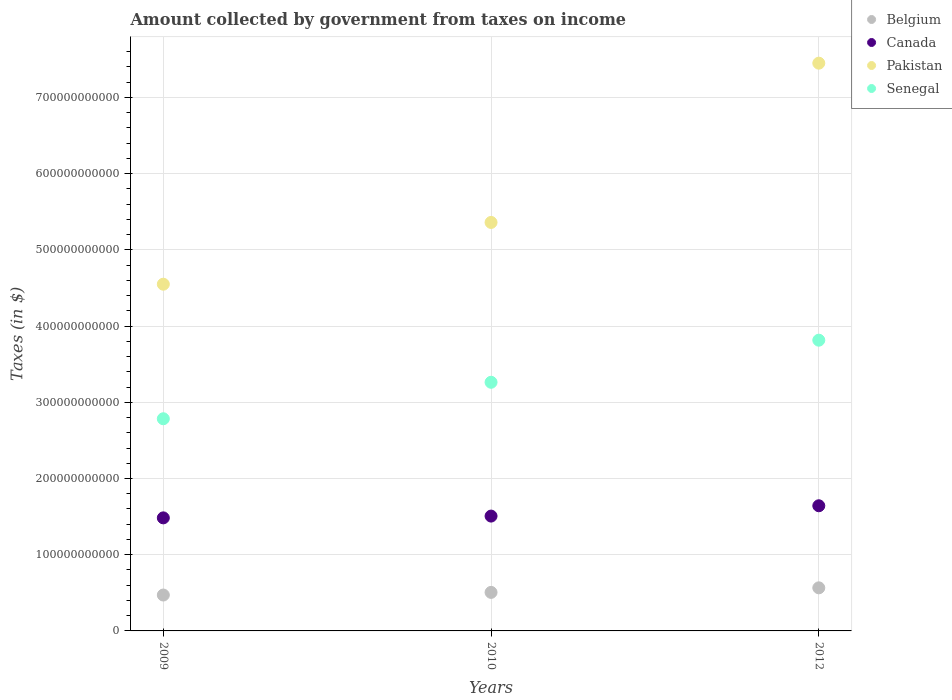How many different coloured dotlines are there?
Make the answer very short. 4. What is the amount collected by government from taxes on income in Senegal in 2010?
Offer a terse response. 3.26e+11. Across all years, what is the maximum amount collected by government from taxes on income in Belgium?
Your answer should be very brief. 5.65e+1. Across all years, what is the minimum amount collected by government from taxes on income in Belgium?
Provide a short and direct response. 4.71e+1. In which year was the amount collected by government from taxes on income in Senegal maximum?
Keep it short and to the point. 2012. What is the total amount collected by government from taxes on income in Pakistan in the graph?
Provide a succinct answer. 1.74e+12. What is the difference between the amount collected by government from taxes on income in Belgium in 2009 and that in 2012?
Your answer should be compact. -9.45e+09. What is the difference between the amount collected by government from taxes on income in Senegal in 2012 and the amount collected by government from taxes on income in Belgium in 2009?
Your answer should be compact. 3.34e+11. What is the average amount collected by government from taxes on income in Pakistan per year?
Your response must be concise. 5.79e+11. In the year 2012, what is the difference between the amount collected by government from taxes on income in Senegal and amount collected by government from taxes on income in Canada?
Your answer should be very brief. 2.17e+11. What is the ratio of the amount collected by government from taxes on income in Senegal in 2010 to that in 2012?
Ensure brevity in your answer.  0.86. Is the difference between the amount collected by government from taxes on income in Senegal in 2009 and 2010 greater than the difference between the amount collected by government from taxes on income in Canada in 2009 and 2010?
Provide a short and direct response. No. What is the difference between the highest and the second highest amount collected by government from taxes on income in Belgium?
Ensure brevity in your answer.  5.98e+09. What is the difference between the highest and the lowest amount collected by government from taxes on income in Senegal?
Your response must be concise. 1.03e+11. Is the sum of the amount collected by government from taxes on income in Canada in 2009 and 2012 greater than the maximum amount collected by government from taxes on income in Belgium across all years?
Your answer should be very brief. Yes. Is it the case that in every year, the sum of the amount collected by government from taxes on income in Pakistan and amount collected by government from taxes on income in Senegal  is greater than the amount collected by government from taxes on income in Canada?
Provide a short and direct response. Yes. How many dotlines are there?
Provide a short and direct response. 4. What is the difference between two consecutive major ticks on the Y-axis?
Provide a short and direct response. 1.00e+11. Where does the legend appear in the graph?
Provide a succinct answer. Top right. How are the legend labels stacked?
Your answer should be compact. Vertical. What is the title of the graph?
Ensure brevity in your answer.  Amount collected by government from taxes on income. What is the label or title of the X-axis?
Give a very brief answer. Years. What is the label or title of the Y-axis?
Your answer should be very brief. Taxes (in $). What is the Taxes (in $) in Belgium in 2009?
Offer a very short reply. 4.71e+1. What is the Taxes (in $) of Canada in 2009?
Keep it short and to the point. 1.48e+11. What is the Taxes (in $) in Pakistan in 2009?
Give a very brief answer. 4.55e+11. What is the Taxes (in $) in Senegal in 2009?
Make the answer very short. 2.78e+11. What is the Taxes (in $) in Belgium in 2010?
Make the answer very short. 5.06e+1. What is the Taxes (in $) in Canada in 2010?
Provide a succinct answer. 1.51e+11. What is the Taxes (in $) in Pakistan in 2010?
Make the answer very short. 5.36e+11. What is the Taxes (in $) of Senegal in 2010?
Your answer should be very brief. 3.26e+11. What is the Taxes (in $) in Belgium in 2012?
Your response must be concise. 5.65e+1. What is the Taxes (in $) in Canada in 2012?
Give a very brief answer. 1.64e+11. What is the Taxes (in $) in Pakistan in 2012?
Provide a short and direct response. 7.45e+11. What is the Taxes (in $) in Senegal in 2012?
Make the answer very short. 3.82e+11. Across all years, what is the maximum Taxes (in $) in Belgium?
Your response must be concise. 5.65e+1. Across all years, what is the maximum Taxes (in $) in Canada?
Provide a succinct answer. 1.64e+11. Across all years, what is the maximum Taxes (in $) of Pakistan?
Your response must be concise. 7.45e+11. Across all years, what is the maximum Taxes (in $) in Senegal?
Your answer should be compact. 3.82e+11. Across all years, what is the minimum Taxes (in $) of Belgium?
Your response must be concise. 4.71e+1. Across all years, what is the minimum Taxes (in $) in Canada?
Give a very brief answer. 1.48e+11. Across all years, what is the minimum Taxes (in $) of Pakistan?
Provide a short and direct response. 4.55e+11. Across all years, what is the minimum Taxes (in $) of Senegal?
Your answer should be very brief. 2.78e+11. What is the total Taxes (in $) of Belgium in the graph?
Provide a short and direct response. 1.54e+11. What is the total Taxes (in $) in Canada in the graph?
Provide a succinct answer. 4.63e+11. What is the total Taxes (in $) in Pakistan in the graph?
Offer a very short reply. 1.74e+12. What is the total Taxes (in $) of Senegal in the graph?
Keep it short and to the point. 9.86e+11. What is the difference between the Taxes (in $) of Belgium in 2009 and that in 2010?
Give a very brief answer. -3.46e+09. What is the difference between the Taxes (in $) of Canada in 2009 and that in 2010?
Offer a terse response. -2.34e+09. What is the difference between the Taxes (in $) of Pakistan in 2009 and that in 2010?
Your response must be concise. -8.10e+1. What is the difference between the Taxes (in $) of Senegal in 2009 and that in 2010?
Make the answer very short. -4.79e+1. What is the difference between the Taxes (in $) of Belgium in 2009 and that in 2012?
Provide a short and direct response. -9.45e+09. What is the difference between the Taxes (in $) of Canada in 2009 and that in 2012?
Ensure brevity in your answer.  -1.59e+1. What is the difference between the Taxes (in $) of Pakistan in 2009 and that in 2012?
Give a very brief answer. -2.90e+11. What is the difference between the Taxes (in $) of Senegal in 2009 and that in 2012?
Keep it short and to the point. -1.03e+11. What is the difference between the Taxes (in $) in Belgium in 2010 and that in 2012?
Give a very brief answer. -5.98e+09. What is the difference between the Taxes (in $) in Canada in 2010 and that in 2012?
Ensure brevity in your answer.  -1.35e+1. What is the difference between the Taxes (in $) in Pakistan in 2010 and that in 2012?
Offer a terse response. -2.09e+11. What is the difference between the Taxes (in $) in Senegal in 2010 and that in 2012?
Offer a very short reply. -5.52e+1. What is the difference between the Taxes (in $) of Belgium in 2009 and the Taxes (in $) of Canada in 2010?
Provide a short and direct response. -1.04e+11. What is the difference between the Taxes (in $) in Belgium in 2009 and the Taxes (in $) in Pakistan in 2010?
Your response must be concise. -4.89e+11. What is the difference between the Taxes (in $) in Belgium in 2009 and the Taxes (in $) in Senegal in 2010?
Keep it short and to the point. -2.79e+11. What is the difference between the Taxes (in $) of Canada in 2009 and the Taxes (in $) of Pakistan in 2010?
Provide a succinct answer. -3.88e+11. What is the difference between the Taxes (in $) of Canada in 2009 and the Taxes (in $) of Senegal in 2010?
Offer a very short reply. -1.78e+11. What is the difference between the Taxes (in $) of Pakistan in 2009 and the Taxes (in $) of Senegal in 2010?
Your response must be concise. 1.29e+11. What is the difference between the Taxes (in $) in Belgium in 2009 and the Taxes (in $) in Canada in 2012?
Provide a short and direct response. -1.17e+11. What is the difference between the Taxes (in $) of Belgium in 2009 and the Taxes (in $) of Pakistan in 2012?
Your response must be concise. -6.98e+11. What is the difference between the Taxes (in $) in Belgium in 2009 and the Taxes (in $) in Senegal in 2012?
Ensure brevity in your answer.  -3.34e+11. What is the difference between the Taxes (in $) in Canada in 2009 and the Taxes (in $) in Pakistan in 2012?
Provide a succinct answer. -5.97e+11. What is the difference between the Taxes (in $) of Canada in 2009 and the Taxes (in $) of Senegal in 2012?
Offer a very short reply. -2.33e+11. What is the difference between the Taxes (in $) in Pakistan in 2009 and the Taxes (in $) in Senegal in 2012?
Offer a terse response. 7.35e+1. What is the difference between the Taxes (in $) in Belgium in 2010 and the Taxes (in $) in Canada in 2012?
Offer a terse response. -1.14e+11. What is the difference between the Taxes (in $) of Belgium in 2010 and the Taxes (in $) of Pakistan in 2012?
Offer a very short reply. -6.94e+11. What is the difference between the Taxes (in $) in Belgium in 2010 and the Taxes (in $) in Senegal in 2012?
Give a very brief answer. -3.31e+11. What is the difference between the Taxes (in $) in Canada in 2010 and the Taxes (in $) in Pakistan in 2012?
Your answer should be very brief. -5.94e+11. What is the difference between the Taxes (in $) of Canada in 2010 and the Taxes (in $) of Senegal in 2012?
Your answer should be very brief. -2.31e+11. What is the difference between the Taxes (in $) in Pakistan in 2010 and the Taxes (in $) in Senegal in 2012?
Give a very brief answer. 1.54e+11. What is the average Taxes (in $) of Belgium per year?
Your answer should be compact. 5.14e+1. What is the average Taxes (in $) of Canada per year?
Make the answer very short. 1.54e+11. What is the average Taxes (in $) of Pakistan per year?
Your answer should be compact. 5.79e+11. What is the average Taxes (in $) of Senegal per year?
Give a very brief answer. 3.29e+11. In the year 2009, what is the difference between the Taxes (in $) in Belgium and Taxes (in $) in Canada?
Ensure brevity in your answer.  -1.01e+11. In the year 2009, what is the difference between the Taxes (in $) in Belgium and Taxes (in $) in Pakistan?
Make the answer very short. -4.08e+11. In the year 2009, what is the difference between the Taxes (in $) in Belgium and Taxes (in $) in Senegal?
Keep it short and to the point. -2.31e+11. In the year 2009, what is the difference between the Taxes (in $) in Canada and Taxes (in $) in Pakistan?
Offer a terse response. -3.07e+11. In the year 2009, what is the difference between the Taxes (in $) in Canada and Taxes (in $) in Senegal?
Your response must be concise. -1.30e+11. In the year 2009, what is the difference between the Taxes (in $) of Pakistan and Taxes (in $) of Senegal?
Give a very brief answer. 1.77e+11. In the year 2010, what is the difference between the Taxes (in $) of Belgium and Taxes (in $) of Canada?
Your response must be concise. -1.00e+11. In the year 2010, what is the difference between the Taxes (in $) of Belgium and Taxes (in $) of Pakistan?
Make the answer very short. -4.85e+11. In the year 2010, what is the difference between the Taxes (in $) in Belgium and Taxes (in $) in Senegal?
Give a very brief answer. -2.76e+11. In the year 2010, what is the difference between the Taxes (in $) in Canada and Taxes (in $) in Pakistan?
Give a very brief answer. -3.85e+11. In the year 2010, what is the difference between the Taxes (in $) in Canada and Taxes (in $) in Senegal?
Provide a short and direct response. -1.76e+11. In the year 2010, what is the difference between the Taxes (in $) of Pakistan and Taxes (in $) of Senegal?
Make the answer very short. 2.10e+11. In the year 2012, what is the difference between the Taxes (in $) in Belgium and Taxes (in $) in Canada?
Provide a short and direct response. -1.08e+11. In the year 2012, what is the difference between the Taxes (in $) of Belgium and Taxes (in $) of Pakistan?
Offer a terse response. -6.88e+11. In the year 2012, what is the difference between the Taxes (in $) in Belgium and Taxes (in $) in Senegal?
Ensure brevity in your answer.  -3.25e+11. In the year 2012, what is the difference between the Taxes (in $) of Canada and Taxes (in $) of Pakistan?
Offer a terse response. -5.81e+11. In the year 2012, what is the difference between the Taxes (in $) in Canada and Taxes (in $) in Senegal?
Your response must be concise. -2.17e+11. In the year 2012, what is the difference between the Taxes (in $) of Pakistan and Taxes (in $) of Senegal?
Offer a terse response. 3.64e+11. What is the ratio of the Taxes (in $) in Belgium in 2009 to that in 2010?
Keep it short and to the point. 0.93. What is the ratio of the Taxes (in $) in Canada in 2009 to that in 2010?
Keep it short and to the point. 0.98. What is the ratio of the Taxes (in $) of Pakistan in 2009 to that in 2010?
Keep it short and to the point. 0.85. What is the ratio of the Taxes (in $) of Senegal in 2009 to that in 2010?
Ensure brevity in your answer.  0.85. What is the ratio of the Taxes (in $) of Belgium in 2009 to that in 2012?
Provide a succinct answer. 0.83. What is the ratio of the Taxes (in $) in Canada in 2009 to that in 2012?
Offer a terse response. 0.9. What is the ratio of the Taxes (in $) in Pakistan in 2009 to that in 2012?
Keep it short and to the point. 0.61. What is the ratio of the Taxes (in $) in Senegal in 2009 to that in 2012?
Ensure brevity in your answer.  0.73. What is the ratio of the Taxes (in $) of Belgium in 2010 to that in 2012?
Keep it short and to the point. 0.89. What is the ratio of the Taxes (in $) in Canada in 2010 to that in 2012?
Ensure brevity in your answer.  0.92. What is the ratio of the Taxes (in $) of Pakistan in 2010 to that in 2012?
Make the answer very short. 0.72. What is the ratio of the Taxes (in $) of Senegal in 2010 to that in 2012?
Your response must be concise. 0.86. What is the difference between the highest and the second highest Taxes (in $) of Belgium?
Your answer should be very brief. 5.98e+09. What is the difference between the highest and the second highest Taxes (in $) of Canada?
Keep it short and to the point. 1.35e+1. What is the difference between the highest and the second highest Taxes (in $) in Pakistan?
Your answer should be very brief. 2.09e+11. What is the difference between the highest and the second highest Taxes (in $) in Senegal?
Your response must be concise. 5.52e+1. What is the difference between the highest and the lowest Taxes (in $) in Belgium?
Keep it short and to the point. 9.45e+09. What is the difference between the highest and the lowest Taxes (in $) of Canada?
Ensure brevity in your answer.  1.59e+1. What is the difference between the highest and the lowest Taxes (in $) in Pakistan?
Give a very brief answer. 2.90e+11. What is the difference between the highest and the lowest Taxes (in $) of Senegal?
Ensure brevity in your answer.  1.03e+11. 